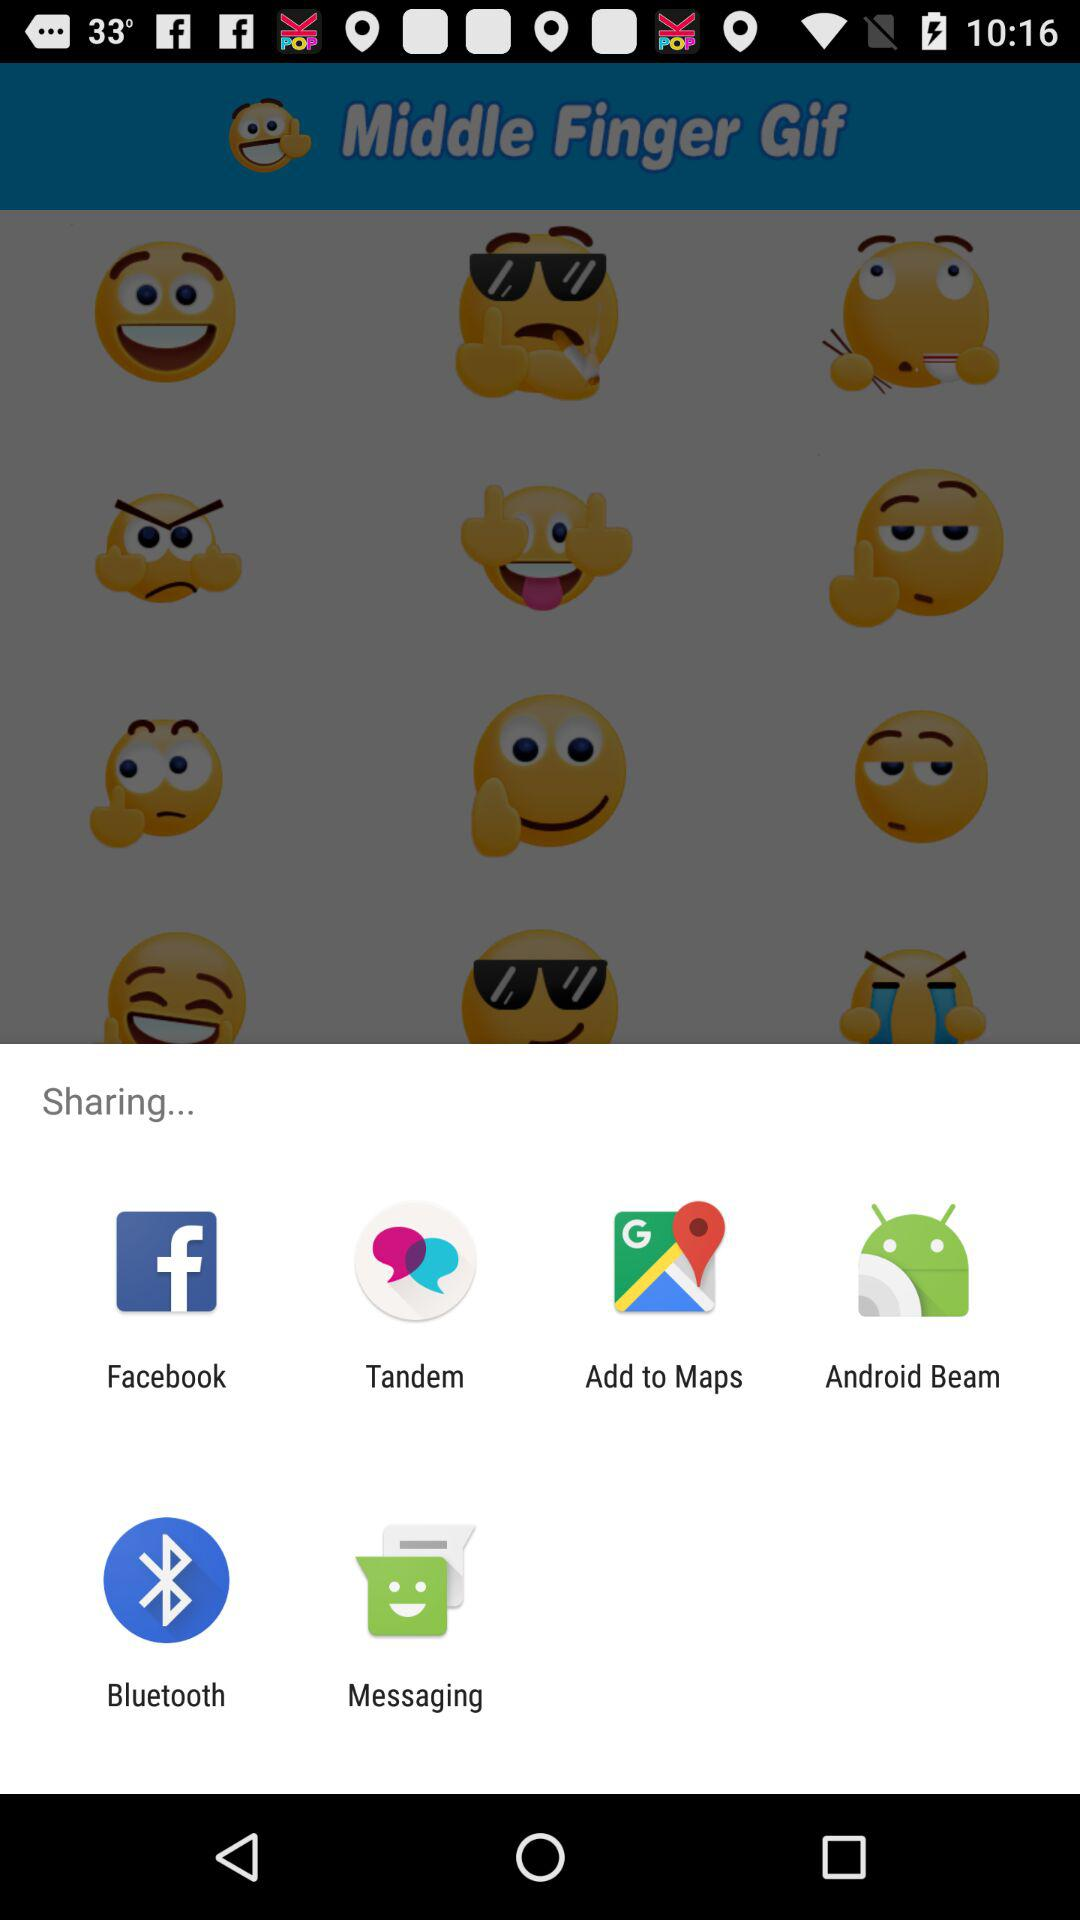How many smiley faces are there in the first row of emojis?
Answer the question using a single word or phrase. 3 